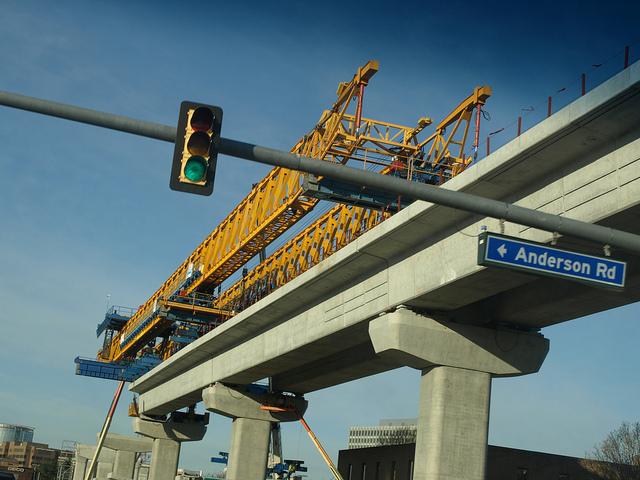What does the sign on this pole read?
Keep it brief. Anderson rd. Is the bridge new or old?
Give a very brief answer. New. What color is the light post?
Keep it brief. Gray. Could this be on-going construction?
Short answer required. Yes. What does the street sign say?
Give a very brief answer. Anderson rd. Can you tell the color of the light from this location?
Short answer required. Yes. What kind of weather it is?
Keep it brief. Sunny. 